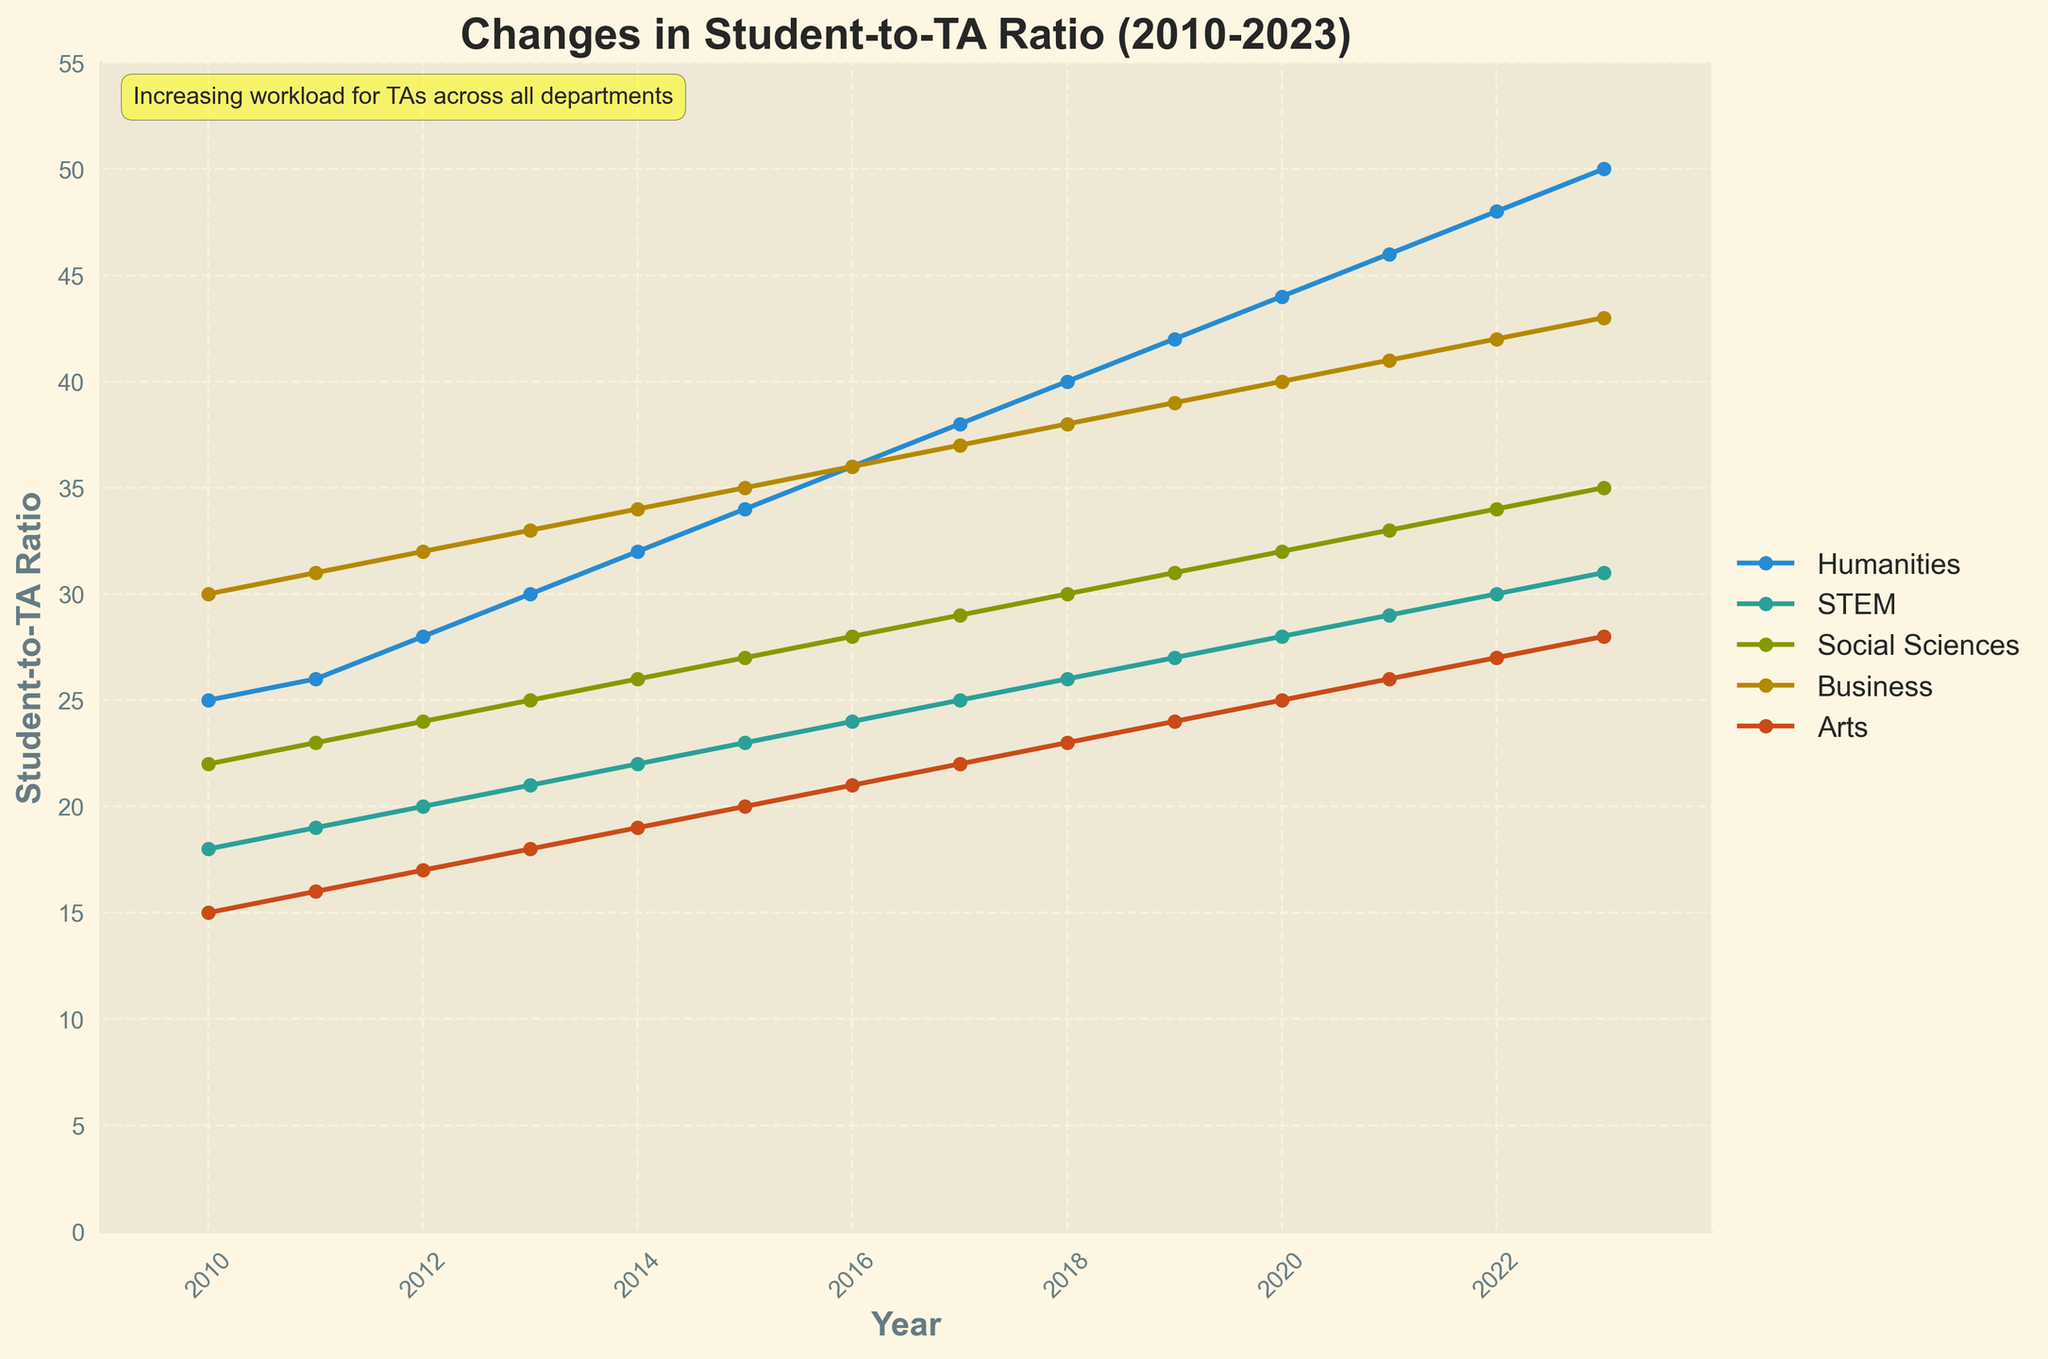What was the student-to-TA ratio for Humanities in 2013? Look at the point on the Humanities line in the year 2013 and read the corresponding value on the y-axis.
Answer: 30 Which department had the lowest student-to-TA ratio in 2020? Look at the points in the year 2020 for all departments and identify the lowest y-value.
Answer: Arts How did the student-to-TA ratio change in the Business department from 2010 to 2023? Find the values for Business in both 2010 and 2023, and calculate the difference between them (43 - 30).
Answer: 13 What is the overall trend in the student-to-TA ratio across all departments from 2010 to 2023? Observe the general direction of each line from 2010 to 2023. All lines show an upward trend over the years.
Answer: Increasing Which two departments had the closest student-to-TA ratio in 2023 and what was the difference? Compare the 2023 data points of all departments and identify the two with the smallest difference (32 for Arts and 31 for STEM, difference of 1).
Answer: STEM and Arts, 1 In what year did the Humanities student-to-TA ratio surpass 40? Observe the Humanities line and locate the year at which it first exceeds the value of 40 on the y-axis.
Answer: 2018 Compare the student-to-TA ratio growth rate between STEM and Social Sciences from 2010 to 2023. Calculate the difference for each department over the period (31-18 for STEM and 35-22 for Social Sciences, both are 13). Both departments have the same increase.
Answer: Equal During which period did the Arts department see the greatest increase in student-to-TA ratio? Examine the slope of the Arts line and identify the steepest segment. The line increases steadily each year, and the complete period from 2010-2023 should be considered for the cumulative increase.
Answer: 2010-2023 By how much did the STEM student-to-TA ratio increase from 2015 to 2018? Find the ratios for STEM in 2015 and 2018, then subtract the 2015 value from the 2018 value (26 - 23).
Answer: 3 Between 2010 and 2023, which department shows the highest increase in student-to-TA ratio? Calculate the overall increase for each department and compare. Humanities had an increase of 25 (from 25 to 50), which is the highest.
Answer: Humanities 